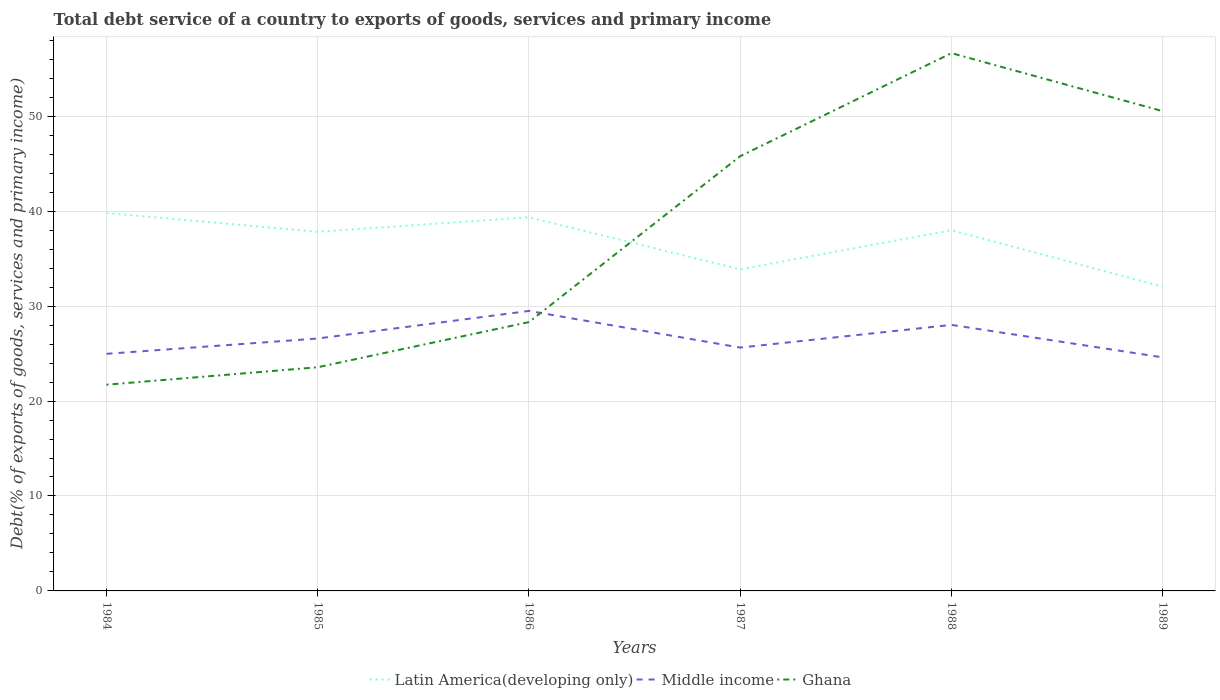How many different coloured lines are there?
Your response must be concise. 3. Does the line corresponding to Latin America(developing only) intersect with the line corresponding to Ghana?
Offer a terse response. Yes. Across all years, what is the maximum total debt service in Middle income?
Offer a terse response. 24.6. What is the total total debt service in Latin America(developing only) in the graph?
Give a very brief answer. -4.12. What is the difference between the highest and the second highest total debt service in Latin America(developing only)?
Provide a succinct answer. 7.76. How many lines are there?
Ensure brevity in your answer.  3. Does the graph contain any zero values?
Offer a terse response. No. Does the graph contain grids?
Make the answer very short. Yes. How are the legend labels stacked?
Your answer should be compact. Horizontal. What is the title of the graph?
Keep it short and to the point. Total debt service of a country to exports of goods, services and primary income. Does "New Zealand" appear as one of the legend labels in the graph?
Make the answer very short. No. What is the label or title of the X-axis?
Your answer should be very brief. Years. What is the label or title of the Y-axis?
Offer a very short reply. Debt(% of exports of goods, services and primary income). What is the Debt(% of exports of goods, services and primary income) in Latin America(developing only) in 1984?
Make the answer very short. 39.81. What is the Debt(% of exports of goods, services and primary income) of Middle income in 1984?
Your answer should be compact. 24.97. What is the Debt(% of exports of goods, services and primary income) of Ghana in 1984?
Provide a succinct answer. 21.72. What is the Debt(% of exports of goods, services and primary income) of Latin America(developing only) in 1985?
Your response must be concise. 37.82. What is the Debt(% of exports of goods, services and primary income) in Middle income in 1985?
Ensure brevity in your answer.  26.59. What is the Debt(% of exports of goods, services and primary income) in Ghana in 1985?
Keep it short and to the point. 23.56. What is the Debt(% of exports of goods, services and primary income) of Latin America(developing only) in 1986?
Your answer should be very brief. 39.35. What is the Debt(% of exports of goods, services and primary income) in Middle income in 1986?
Make the answer very short. 29.49. What is the Debt(% of exports of goods, services and primary income) in Ghana in 1986?
Your answer should be very brief. 28.32. What is the Debt(% of exports of goods, services and primary income) of Latin America(developing only) in 1987?
Keep it short and to the point. 33.87. What is the Debt(% of exports of goods, services and primary income) of Middle income in 1987?
Your response must be concise. 25.63. What is the Debt(% of exports of goods, services and primary income) of Ghana in 1987?
Your answer should be compact. 45.79. What is the Debt(% of exports of goods, services and primary income) of Latin America(developing only) in 1988?
Offer a terse response. 37.99. What is the Debt(% of exports of goods, services and primary income) in Middle income in 1988?
Give a very brief answer. 28.02. What is the Debt(% of exports of goods, services and primary income) of Ghana in 1988?
Your response must be concise. 56.64. What is the Debt(% of exports of goods, services and primary income) in Latin America(developing only) in 1989?
Provide a short and direct response. 32.04. What is the Debt(% of exports of goods, services and primary income) in Middle income in 1989?
Your answer should be very brief. 24.6. What is the Debt(% of exports of goods, services and primary income) of Ghana in 1989?
Give a very brief answer. 50.53. Across all years, what is the maximum Debt(% of exports of goods, services and primary income) in Latin America(developing only)?
Provide a short and direct response. 39.81. Across all years, what is the maximum Debt(% of exports of goods, services and primary income) of Middle income?
Your response must be concise. 29.49. Across all years, what is the maximum Debt(% of exports of goods, services and primary income) in Ghana?
Ensure brevity in your answer.  56.64. Across all years, what is the minimum Debt(% of exports of goods, services and primary income) of Latin America(developing only)?
Ensure brevity in your answer.  32.04. Across all years, what is the minimum Debt(% of exports of goods, services and primary income) in Middle income?
Your answer should be compact. 24.6. Across all years, what is the minimum Debt(% of exports of goods, services and primary income) in Ghana?
Offer a very short reply. 21.72. What is the total Debt(% of exports of goods, services and primary income) of Latin America(developing only) in the graph?
Your answer should be compact. 220.88. What is the total Debt(% of exports of goods, services and primary income) in Middle income in the graph?
Offer a very short reply. 159.3. What is the total Debt(% of exports of goods, services and primary income) of Ghana in the graph?
Offer a very short reply. 226.56. What is the difference between the Debt(% of exports of goods, services and primary income) in Latin America(developing only) in 1984 and that in 1985?
Provide a succinct answer. 1.99. What is the difference between the Debt(% of exports of goods, services and primary income) in Middle income in 1984 and that in 1985?
Provide a succinct answer. -1.61. What is the difference between the Debt(% of exports of goods, services and primary income) of Ghana in 1984 and that in 1985?
Keep it short and to the point. -1.84. What is the difference between the Debt(% of exports of goods, services and primary income) in Latin America(developing only) in 1984 and that in 1986?
Provide a succinct answer. 0.45. What is the difference between the Debt(% of exports of goods, services and primary income) in Middle income in 1984 and that in 1986?
Your answer should be very brief. -4.52. What is the difference between the Debt(% of exports of goods, services and primary income) of Ghana in 1984 and that in 1986?
Offer a very short reply. -6.6. What is the difference between the Debt(% of exports of goods, services and primary income) of Latin America(developing only) in 1984 and that in 1987?
Provide a succinct answer. 5.94. What is the difference between the Debt(% of exports of goods, services and primary income) in Middle income in 1984 and that in 1987?
Make the answer very short. -0.66. What is the difference between the Debt(% of exports of goods, services and primary income) in Ghana in 1984 and that in 1987?
Offer a very short reply. -24.07. What is the difference between the Debt(% of exports of goods, services and primary income) of Latin America(developing only) in 1984 and that in 1988?
Offer a very short reply. 1.81. What is the difference between the Debt(% of exports of goods, services and primary income) of Middle income in 1984 and that in 1988?
Your answer should be very brief. -3.05. What is the difference between the Debt(% of exports of goods, services and primary income) in Ghana in 1984 and that in 1988?
Keep it short and to the point. -34.92. What is the difference between the Debt(% of exports of goods, services and primary income) in Latin America(developing only) in 1984 and that in 1989?
Your response must be concise. 7.76. What is the difference between the Debt(% of exports of goods, services and primary income) in Middle income in 1984 and that in 1989?
Ensure brevity in your answer.  0.37. What is the difference between the Debt(% of exports of goods, services and primary income) of Ghana in 1984 and that in 1989?
Ensure brevity in your answer.  -28.81. What is the difference between the Debt(% of exports of goods, services and primary income) of Latin America(developing only) in 1985 and that in 1986?
Offer a terse response. -1.53. What is the difference between the Debt(% of exports of goods, services and primary income) in Middle income in 1985 and that in 1986?
Your answer should be very brief. -2.9. What is the difference between the Debt(% of exports of goods, services and primary income) of Ghana in 1985 and that in 1986?
Give a very brief answer. -4.76. What is the difference between the Debt(% of exports of goods, services and primary income) of Latin America(developing only) in 1985 and that in 1987?
Offer a very short reply. 3.95. What is the difference between the Debt(% of exports of goods, services and primary income) in Middle income in 1985 and that in 1987?
Offer a very short reply. 0.96. What is the difference between the Debt(% of exports of goods, services and primary income) in Ghana in 1985 and that in 1987?
Your answer should be very brief. -22.23. What is the difference between the Debt(% of exports of goods, services and primary income) of Latin America(developing only) in 1985 and that in 1988?
Your answer should be compact. -0.17. What is the difference between the Debt(% of exports of goods, services and primary income) in Middle income in 1985 and that in 1988?
Provide a short and direct response. -1.43. What is the difference between the Debt(% of exports of goods, services and primary income) of Ghana in 1985 and that in 1988?
Your answer should be compact. -33.08. What is the difference between the Debt(% of exports of goods, services and primary income) in Latin America(developing only) in 1985 and that in 1989?
Your response must be concise. 5.78. What is the difference between the Debt(% of exports of goods, services and primary income) in Middle income in 1985 and that in 1989?
Provide a short and direct response. 1.99. What is the difference between the Debt(% of exports of goods, services and primary income) of Ghana in 1985 and that in 1989?
Keep it short and to the point. -26.97. What is the difference between the Debt(% of exports of goods, services and primary income) of Latin America(developing only) in 1986 and that in 1987?
Your answer should be compact. 5.48. What is the difference between the Debt(% of exports of goods, services and primary income) of Middle income in 1986 and that in 1987?
Ensure brevity in your answer.  3.86. What is the difference between the Debt(% of exports of goods, services and primary income) in Ghana in 1986 and that in 1987?
Provide a succinct answer. -17.47. What is the difference between the Debt(% of exports of goods, services and primary income) in Latin America(developing only) in 1986 and that in 1988?
Your answer should be very brief. 1.36. What is the difference between the Debt(% of exports of goods, services and primary income) of Middle income in 1986 and that in 1988?
Ensure brevity in your answer.  1.47. What is the difference between the Debt(% of exports of goods, services and primary income) of Ghana in 1986 and that in 1988?
Your answer should be compact. -28.32. What is the difference between the Debt(% of exports of goods, services and primary income) in Latin America(developing only) in 1986 and that in 1989?
Your answer should be very brief. 7.31. What is the difference between the Debt(% of exports of goods, services and primary income) of Middle income in 1986 and that in 1989?
Provide a succinct answer. 4.89. What is the difference between the Debt(% of exports of goods, services and primary income) in Ghana in 1986 and that in 1989?
Your answer should be compact. -22.21. What is the difference between the Debt(% of exports of goods, services and primary income) of Latin America(developing only) in 1987 and that in 1988?
Your response must be concise. -4.12. What is the difference between the Debt(% of exports of goods, services and primary income) of Middle income in 1987 and that in 1988?
Your response must be concise. -2.39. What is the difference between the Debt(% of exports of goods, services and primary income) of Ghana in 1987 and that in 1988?
Offer a terse response. -10.85. What is the difference between the Debt(% of exports of goods, services and primary income) in Latin America(developing only) in 1987 and that in 1989?
Offer a terse response. 1.83. What is the difference between the Debt(% of exports of goods, services and primary income) in Middle income in 1987 and that in 1989?
Make the answer very short. 1.03. What is the difference between the Debt(% of exports of goods, services and primary income) in Ghana in 1987 and that in 1989?
Your answer should be compact. -4.74. What is the difference between the Debt(% of exports of goods, services and primary income) of Latin America(developing only) in 1988 and that in 1989?
Your response must be concise. 5.95. What is the difference between the Debt(% of exports of goods, services and primary income) of Middle income in 1988 and that in 1989?
Ensure brevity in your answer.  3.42. What is the difference between the Debt(% of exports of goods, services and primary income) in Ghana in 1988 and that in 1989?
Your response must be concise. 6.11. What is the difference between the Debt(% of exports of goods, services and primary income) of Latin America(developing only) in 1984 and the Debt(% of exports of goods, services and primary income) of Middle income in 1985?
Offer a very short reply. 13.22. What is the difference between the Debt(% of exports of goods, services and primary income) of Latin America(developing only) in 1984 and the Debt(% of exports of goods, services and primary income) of Ghana in 1985?
Keep it short and to the point. 16.25. What is the difference between the Debt(% of exports of goods, services and primary income) of Middle income in 1984 and the Debt(% of exports of goods, services and primary income) of Ghana in 1985?
Provide a short and direct response. 1.41. What is the difference between the Debt(% of exports of goods, services and primary income) in Latin America(developing only) in 1984 and the Debt(% of exports of goods, services and primary income) in Middle income in 1986?
Offer a very short reply. 10.32. What is the difference between the Debt(% of exports of goods, services and primary income) of Latin America(developing only) in 1984 and the Debt(% of exports of goods, services and primary income) of Ghana in 1986?
Make the answer very short. 11.49. What is the difference between the Debt(% of exports of goods, services and primary income) in Middle income in 1984 and the Debt(% of exports of goods, services and primary income) in Ghana in 1986?
Provide a short and direct response. -3.34. What is the difference between the Debt(% of exports of goods, services and primary income) of Latin America(developing only) in 1984 and the Debt(% of exports of goods, services and primary income) of Middle income in 1987?
Offer a terse response. 14.18. What is the difference between the Debt(% of exports of goods, services and primary income) in Latin America(developing only) in 1984 and the Debt(% of exports of goods, services and primary income) in Ghana in 1987?
Ensure brevity in your answer.  -5.98. What is the difference between the Debt(% of exports of goods, services and primary income) of Middle income in 1984 and the Debt(% of exports of goods, services and primary income) of Ghana in 1987?
Your response must be concise. -20.82. What is the difference between the Debt(% of exports of goods, services and primary income) of Latin America(developing only) in 1984 and the Debt(% of exports of goods, services and primary income) of Middle income in 1988?
Keep it short and to the point. 11.79. What is the difference between the Debt(% of exports of goods, services and primary income) in Latin America(developing only) in 1984 and the Debt(% of exports of goods, services and primary income) in Ghana in 1988?
Keep it short and to the point. -16.83. What is the difference between the Debt(% of exports of goods, services and primary income) in Middle income in 1984 and the Debt(% of exports of goods, services and primary income) in Ghana in 1988?
Provide a short and direct response. -31.67. What is the difference between the Debt(% of exports of goods, services and primary income) of Latin America(developing only) in 1984 and the Debt(% of exports of goods, services and primary income) of Middle income in 1989?
Offer a terse response. 15.21. What is the difference between the Debt(% of exports of goods, services and primary income) of Latin America(developing only) in 1984 and the Debt(% of exports of goods, services and primary income) of Ghana in 1989?
Make the answer very short. -10.72. What is the difference between the Debt(% of exports of goods, services and primary income) in Middle income in 1984 and the Debt(% of exports of goods, services and primary income) in Ghana in 1989?
Offer a very short reply. -25.56. What is the difference between the Debt(% of exports of goods, services and primary income) in Latin America(developing only) in 1985 and the Debt(% of exports of goods, services and primary income) in Middle income in 1986?
Keep it short and to the point. 8.33. What is the difference between the Debt(% of exports of goods, services and primary income) of Latin America(developing only) in 1985 and the Debt(% of exports of goods, services and primary income) of Ghana in 1986?
Your answer should be very brief. 9.5. What is the difference between the Debt(% of exports of goods, services and primary income) in Middle income in 1985 and the Debt(% of exports of goods, services and primary income) in Ghana in 1986?
Keep it short and to the point. -1.73. What is the difference between the Debt(% of exports of goods, services and primary income) of Latin America(developing only) in 1985 and the Debt(% of exports of goods, services and primary income) of Middle income in 1987?
Your answer should be compact. 12.19. What is the difference between the Debt(% of exports of goods, services and primary income) of Latin America(developing only) in 1985 and the Debt(% of exports of goods, services and primary income) of Ghana in 1987?
Ensure brevity in your answer.  -7.97. What is the difference between the Debt(% of exports of goods, services and primary income) of Middle income in 1985 and the Debt(% of exports of goods, services and primary income) of Ghana in 1987?
Offer a very short reply. -19.2. What is the difference between the Debt(% of exports of goods, services and primary income) in Latin America(developing only) in 1985 and the Debt(% of exports of goods, services and primary income) in Middle income in 1988?
Your response must be concise. 9.8. What is the difference between the Debt(% of exports of goods, services and primary income) in Latin America(developing only) in 1985 and the Debt(% of exports of goods, services and primary income) in Ghana in 1988?
Ensure brevity in your answer.  -18.82. What is the difference between the Debt(% of exports of goods, services and primary income) in Middle income in 1985 and the Debt(% of exports of goods, services and primary income) in Ghana in 1988?
Your answer should be compact. -30.05. What is the difference between the Debt(% of exports of goods, services and primary income) of Latin America(developing only) in 1985 and the Debt(% of exports of goods, services and primary income) of Middle income in 1989?
Your response must be concise. 13.22. What is the difference between the Debt(% of exports of goods, services and primary income) of Latin America(developing only) in 1985 and the Debt(% of exports of goods, services and primary income) of Ghana in 1989?
Your answer should be very brief. -12.71. What is the difference between the Debt(% of exports of goods, services and primary income) of Middle income in 1985 and the Debt(% of exports of goods, services and primary income) of Ghana in 1989?
Keep it short and to the point. -23.94. What is the difference between the Debt(% of exports of goods, services and primary income) of Latin America(developing only) in 1986 and the Debt(% of exports of goods, services and primary income) of Middle income in 1987?
Ensure brevity in your answer.  13.72. What is the difference between the Debt(% of exports of goods, services and primary income) in Latin America(developing only) in 1986 and the Debt(% of exports of goods, services and primary income) in Ghana in 1987?
Offer a very short reply. -6.44. What is the difference between the Debt(% of exports of goods, services and primary income) in Middle income in 1986 and the Debt(% of exports of goods, services and primary income) in Ghana in 1987?
Ensure brevity in your answer.  -16.3. What is the difference between the Debt(% of exports of goods, services and primary income) of Latin America(developing only) in 1986 and the Debt(% of exports of goods, services and primary income) of Middle income in 1988?
Keep it short and to the point. 11.33. What is the difference between the Debt(% of exports of goods, services and primary income) in Latin America(developing only) in 1986 and the Debt(% of exports of goods, services and primary income) in Ghana in 1988?
Make the answer very short. -17.29. What is the difference between the Debt(% of exports of goods, services and primary income) in Middle income in 1986 and the Debt(% of exports of goods, services and primary income) in Ghana in 1988?
Offer a terse response. -27.15. What is the difference between the Debt(% of exports of goods, services and primary income) of Latin America(developing only) in 1986 and the Debt(% of exports of goods, services and primary income) of Middle income in 1989?
Ensure brevity in your answer.  14.75. What is the difference between the Debt(% of exports of goods, services and primary income) in Latin America(developing only) in 1986 and the Debt(% of exports of goods, services and primary income) in Ghana in 1989?
Give a very brief answer. -11.18. What is the difference between the Debt(% of exports of goods, services and primary income) in Middle income in 1986 and the Debt(% of exports of goods, services and primary income) in Ghana in 1989?
Make the answer very short. -21.04. What is the difference between the Debt(% of exports of goods, services and primary income) of Latin America(developing only) in 1987 and the Debt(% of exports of goods, services and primary income) of Middle income in 1988?
Offer a very short reply. 5.85. What is the difference between the Debt(% of exports of goods, services and primary income) of Latin America(developing only) in 1987 and the Debt(% of exports of goods, services and primary income) of Ghana in 1988?
Provide a short and direct response. -22.77. What is the difference between the Debt(% of exports of goods, services and primary income) of Middle income in 1987 and the Debt(% of exports of goods, services and primary income) of Ghana in 1988?
Offer a terse response. -31.01. What is the difference between the Debt(% of exports of goods, services and primary income) in Latin America(developing only) in 1987 and the Debt(% of exports of goods, services and primary income) in Middle income in 1989?
Offer a very short reply. 9.27. What is the difference between the Debt(% of exports of goods, services and primary income) in Latin America(developing only) in 1987 and the Debt(% of exports of goods, services and primary income) in Ghana in 1989?
Offer a terse response. -16.66. What is the difference between the Debt(% of exports of goods, services and primary income) of Middle income in 1987 and the Debt(% of exports of goods, services and primary income) of Ghana in 1989?
Keep it short and to the point. -24.9. What is the difference between the Debt(% of exports of goods, services and primary income) in Latin America(developing only) in 1988 and the Debt(% of exports of goods, services and primary income) in Middle income in 1989?
Provide a short and direct response. 13.39. What is the difference between the Debt(% of exports of goods, services and primary income) of Latin America(developing only) in 1988 and the Debt(% of exports of goods, services and primary income) of Ghana in 1989?
Give a very brief answer. -12.54. What is the difference between the Debt(% of exports of goods, services and primary income) in Middle income in 1988 and the Debt(% of exports of goods, services and primary income) in Ghana in 1989?
Make the answer very short. -22.51. What is the average Debt(% of exports of goods, services and primary income) in Latin America(developing only) per year?
Offer a very short reply. 36.81. What is the average Debt(% of exports of goods, services and primary income) of Middle income per year?
Make the answer very short. 26.55. What is the average Debt(% of exports of goods, services and primary income) of Ghana per year?
Give a very brief answer. 37.76. In the year 1984, what is the difference between the Debt(% of exports of goods, services and primary income) in Latin America(developing only) and Debt(% of exports of goods, services and primary income) in Middle income?
Give a very brief answer. 14.83. In the year 1984, what is the difference between the Debt(% of exports of goods, services and primary income) in Latin America(developing only) and Debt(% of exports of goods, services and primary income) in Ghana?
Give a very brief answer. 18.09. In the year 1984, what is the difference between the Debt(% of exports of goods, services and primary income) in Middle income and Debt(% of exports of goods, services and primary income) in Ghana?
Your answer should be compact. 3.25. In the year 1985, what is the difference between the Debt(% of exports of goods, services and primary income) in Latin America(developing only) and Debt(% of exports of goods, services and primary income) in Middle income?
Give a very brief answer. 11.23. In the year 1985, what is the difference between the Debt(% of exports of goods, services and primary income) of Latin America(developing only) and Debt(% of exports of goods, services and primary income) of Ghana?
Give a very brief answer. 14.26. In the year 1985, what is the difference between the Debt(% of exports of goods, services and primary income) of Middle income and Debt(% of exports of goods, services and primary income) of Ghana?
Keep it short and to the point. 3.03. In the year 1986, what is the difference between the Debt(% of exports of goods, services and primary income) of Latin America(developing only) and Debt(% of exports of goods, services and primary income) of Middle income?
Keep it short and to the point. 9.86. In the year 1986, what is the difference between the Debt(% of exports of goods, services and primary income) of Latin America(developing only) and Debt(% of exports of goods, services and primary income) of Ghana?
Your answer should be compact. 11.04. In the year 1986, what is the difference between the Debt(% of exports of goods, services and primary income) of Middle income and Debt(% of exports of goods, services and primary income) of Ghana?
Keep it short and to the point. 1.17. In the year 1987, what is the difference between the Debt(% of exports of goods, services and primary income) of Latin America(developing only) and Debt(% of exports of goods, services and primary income) of Middle income?
Provide a short and direct response. 8.24. In the year 1987, what is the difference between the Debt(% of exports of goods, services and primary income) in Latin America(developing only) and Debt(% of exports of goods, services and primary income) in Ghana?
Your response must be concise. -11.92. In the year 1987, what is the difference between the Debt(% of exports of goods, services and primary income) of Middle income and Debt(% of exports of goods, services and primary income) of Ghana?
Your answer should be compact. -20.16. In the year 1988, what is the difference between the Debt(% of exports of goods, services and primary income) of Latin America(developing only) and Debt(% of exports of goods, services and primary income) of Middle income?
Offer a very short reply. 9.97. In the year 1988, what is the difference between the Debt(% of exports of goods, services and primary income) in Latin America(developing only) and Debt(% of exports of goods, services and primary income) in Ghana?
Provide a succinct answer. -18.65. In the year 1988, what is the difference between the Debt(% of exports of goods, services and primary income) of Middle income and Debt(% of exports of goods, services and primary income) of Ghana?
Give a very brief answer. -28.62. In the year 1989, what is the difference between the Debt(% of exports of goods, services and primary income) in Latin America(developing only) and Debt(% of exports of goods, services and primary income) in Middle income?
Your response must be concise. 7.44. In the year 1989, what is the difference between the Debt(% of exports of goods, services and primary income) of Latin America(developing only) and Debt(% of exports of goods, services and primary income) of Ghana?
Offer a terse response. -18.49. In the year 1989, what is the difference between the Debt(% of exports of goods, services and primary income) in Middle income and Debt(% of exports of goods, services and primary income) in Ghana?
Your answer should be very brief. -25.93. What is the ratio of the Debt(% of exports of goods, services and primary income) of Latin America(developing only) in 1984 to that in 1985?
Provide a succinct answer. 1.05. What is the ratio of the Debt(% of exports of goods, services and primary income) in Middle income in 1984 to that in 1985?
Your answer should be compact. 0.94. What is the ratio of the Debt(% of exports of goods, services and primary income) of Ghana in 1984 to that in 1985?
Keep it short and to the point. 0.92. What is the ratio of the Debt(% of exports of goods, services and primary income) in Latin America(developing only) in 1984 to that in 1986?
Provide a succinct answer. 1.01. What is the ratio of the Debt(% of exports of goods, services and primary income) of Middle income in 1984 to that in 1986?
Give a very brief answer. 0.85. What is the ratio of the Debt(% of exports of goods, services and primary income) in Ghana in 1984 to that in 1986?
Make the answer very short. 0.77. What is the ratio of the Debt(% of exports of goods, services and primary income) in Latin America(developing only) in 1984 to that in 1987?
Give a very brief answer. 1.18. What is the ratio of the Debt(% of exports of goods, services and primary income) in Middle income in 1984 to that in 1987?
Make the answer very short. 0.97. What is the ratio of the Debt(% of exports of goods, services and primary income) in Ghana in 1984 to that in 1987?
Offer a terse response. 0.47. What is the ratio of the Debt(% of exports of goods, services and primary income) in Latin America(developing only) in 1984 to that in 1988?
Provide a succinct answer. 1.05. What is the ratio of the Debt(% of exports of goods, services and primary income) in Middle income in 1984 to that in 1988?
Provide a short and direct response. 0.89. What is the ratio of the Debt(% of exports of goods, services and primary income) in Ghana in 1984 to that in 1988?
Your response must be concise. 0.38. What is the ratio of the Debt(% of exports of goods, services and primary income) in Latin America(developing only) in 1984 to that in 1989?
Your answer should be compact. 1.24. What is the ratio of the Debt(% of exports of goods, services and primary income) in Middle income in 1984 to that in 1989?
Your response must be concise. 1.02. What is the ratio of the Debt(% of exports of goods, services and primary income) in Ghana in 1984 to that in 1989?
Your answer should be compact. 0.43. What is the ratio of the Debt(% of exports of goods, services and primary income) of Middle income in 1985 to that in 1986?
Offer a terse response. 0.9. What is the ratio of the Debt(% of exports of goods, services and primary income) of Ghana in 1985 to that in 1986?
Your answer should be very brief. 0.83. What is the ratio of the Debt(% of exports of goods, services and primary income) in Latin America(developing only) in 1985 to that in 1987?
Your response must be concise. 1.12. What is the ratio of the Debt(% of exports of goods, services and primary income) in Middle income in 1985 to that in 1987?
Provide a short and direct response. 1.04. What is the ratio of the Debt(% of exports of goods, services and primary income) in Ghana in 1985 to that in 1987?
Provide a succinct answer. 0.51. What is the ratio of the Debt(% of exports of goods, services and primary income) in Latin America(developing only) in 1985 to that in 1988?
Ensure brevity in your answer.  1. What is the ratio of the Debt(% of exports of goods, services and primary income) in Middle income in 1985 to that in 1988?
Provide a short and direct response. 0.95. What is the ratio of the Debt(% of exports of goods, services and primary income) of Ghana in 1985 to that in 1988?
Provide a short and direct response. 0.42. What is the ratio of the Debt(% of exports of goods, services and primary income) in Latin America(developing only) in 1985 to that in 1989?
Ensure brevity in your answer.  1.18. What is the ratio of the Debt(% of exports of goods, services and primary income) of Middle income in 1985 to that in 1989?
Your response must be concise. 1.08. What is the ratio of the Debt(% of exports of goods, services and primary income) in Ghana in 1985 to that in 1989?
Provide a short and direct response. 0.47. What is the ratio of the Debt(% of exports of goods, services and primary income) in Latin America(developing only) in 1986 to that in 1987?
Give a very brief answer. 1.16. What is the ratio of the Debt(% of exports of goods, services and primary income) of Middle income in 1986 to that in 1987?
Offer a terse response. 1.15. What is the ratio of the Debt(% of exports of goods, services and primary income) of Ghana in 1986 to that in 1987?
Provide a short and direct response. 0.62. What is the ratio of the Debt(% of exports of goods, services and primary income) of Latin America(developing only) in 1986 to that in 1988?
Ensure brevity in your answer.  1.04. What is the ratio of the Debt(% of exports of goods, services and primary income) of Middle income in 1986 to that in 1988?
Your response must be concise. 1.05. What is the ratio of the Debt(% of exports of goods, services and primary income) of Ghana in 1986 to that in 1988?
Offer a terse response. 0.5. What is the ratio of the Debt(% of exports of goods, services and primary income) of Latin America(developing only) in 1986 to that in 1989?
Provide a short and direct response. 1.23. What is the ratio of the Debt(% of exports of goods, services and primary income) of Middle income in 1986 to that in 1989?
Your response must be concise. 1.2. What is the ratio of the Debt(% of exports of goods, services and primary income) in Ghana in 1986 to that in 1989?
Keep it short and to the point. 0.56. What is the ratio of the Debt(% of exports of goods, services and primary income) of Latin America(developing only) in 1987 to that in 1988?
Give a very brief answer. 0.89. What is the ratio of the Debt(% of exports of goods, services and primary income) in Middle income in 1987 to that in 1988?
Provide a succinct answer. 0.91. What is the ratio of the Debt(% of exports of goods, services and primary income) of Ghana in 1987 to that in 1988?
Offer a terse response. 0.81. What is the ratio of the Debt(% of exports of goods, services and primary income) of Latin America(developing only) in 1987 to that in 1989?
Ensure brevity in your answer.  1.06. What is the ratio of the Debt(% of exports of goods, services and primary income) of Middle income in 1987 to that in 1989?
Give a very brief answer. 1.04. What is the ratio of the Debt(% of exports of goods, services and primary income) of Ghana in 1987 to that in 1989?
Your answer should be very brief. 0.91. What is the ratio of the Debt(% of exports of goods, services and primary income) in Latin America(developing only) in 1988 to that in 1989?
Offer a terse response. 1.19. What is the ratio of the Debt(% of exports of goods, services and primary income) of Middle income in 1988 to that in 1989?
Your answer should be very brief. 1.14. What is the ratio of the Debt(% of exports of goods, services and primary income) of Ghana in 1988 to that in 1989?
Ensure brevity in your answer.  1.12. What is the difference between the highest and the second highest Debt(% of exports of goods, services and primary income) of Latin America(developing only)?
Provide a succinct answer. 0.45. What is the difference between the highest and the second highest Debt(% of exports of goods, services and primary income) of Middle income?
Ensure brevity in your answer.  1.47. What is the difference between the highest and the second highest Debt(% of exports of goods, services and primary income) in Ghana?
Offer a very short reply. 6.11. What is the difference between the highest and the lowest Debt(% of exports of goods, services and primary income) of Latin America(developing only)?
Give a very brief answer. 7.76. What is the difference between the highest and the lowest Debt(% of exports of goods, services and primary income) in Middle income?
Offer a very short reply. 4.89. What is the difference between the highest and the lowest Debt(% of exports of goods, services and primary income) of Ghana?
Provide a succinct answer. 34.92. 